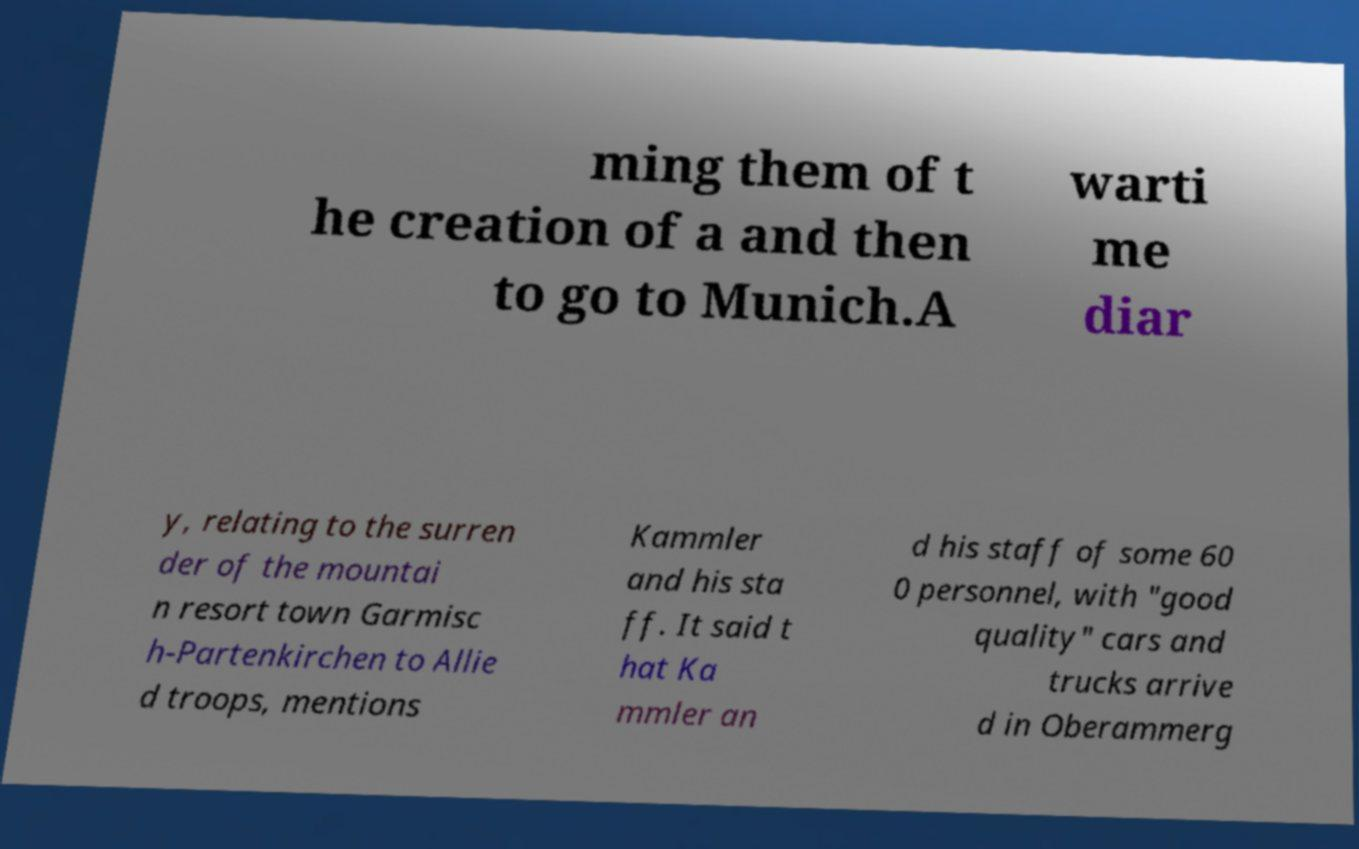What messages or text are displayed in this image? I need them in a readable, typed format. ming them of t he creation of a and then to go to Munich.A warti me diar y, relating to the surren der of the mountai n resort town Garmisc h-Partenkirchen to Allie d troops, mentions Kammler and his sta ff. It said t hat Ka mmler an d his staff of some 60 0 personnel, with "good quality" cars and trucks arrive d in Oberammerg 